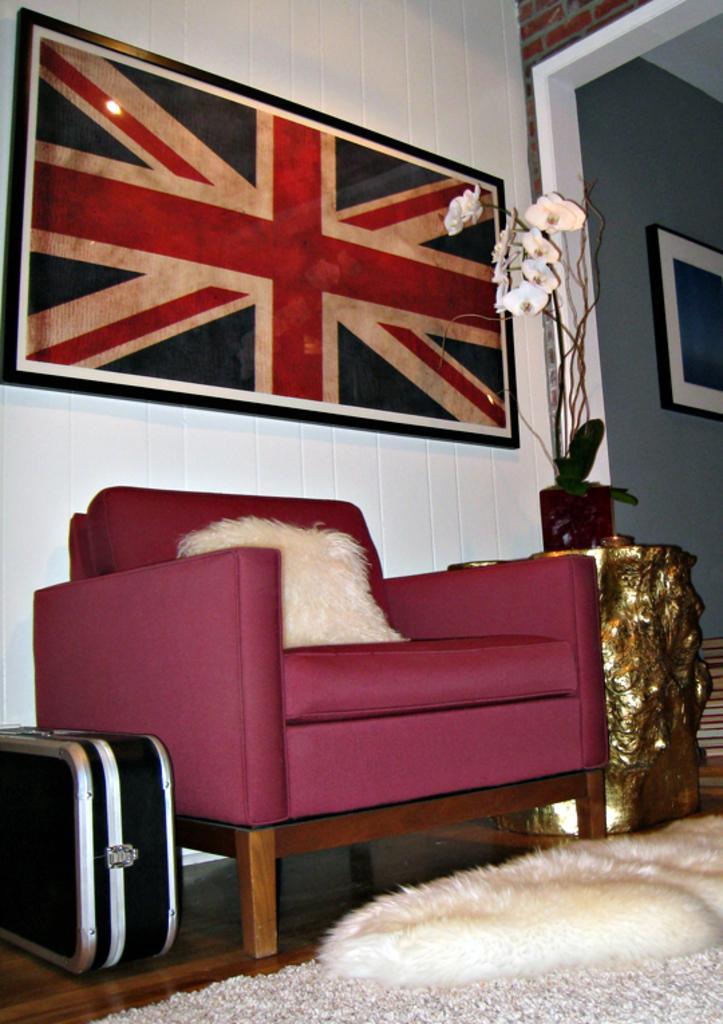In one or two sentences, can you explain what this image depicts? In this picture we can see a red color sofa and a pillow on it and beside the sofa there is a desk in golden color on which there is a flower vase and a floor mat in front of it. 